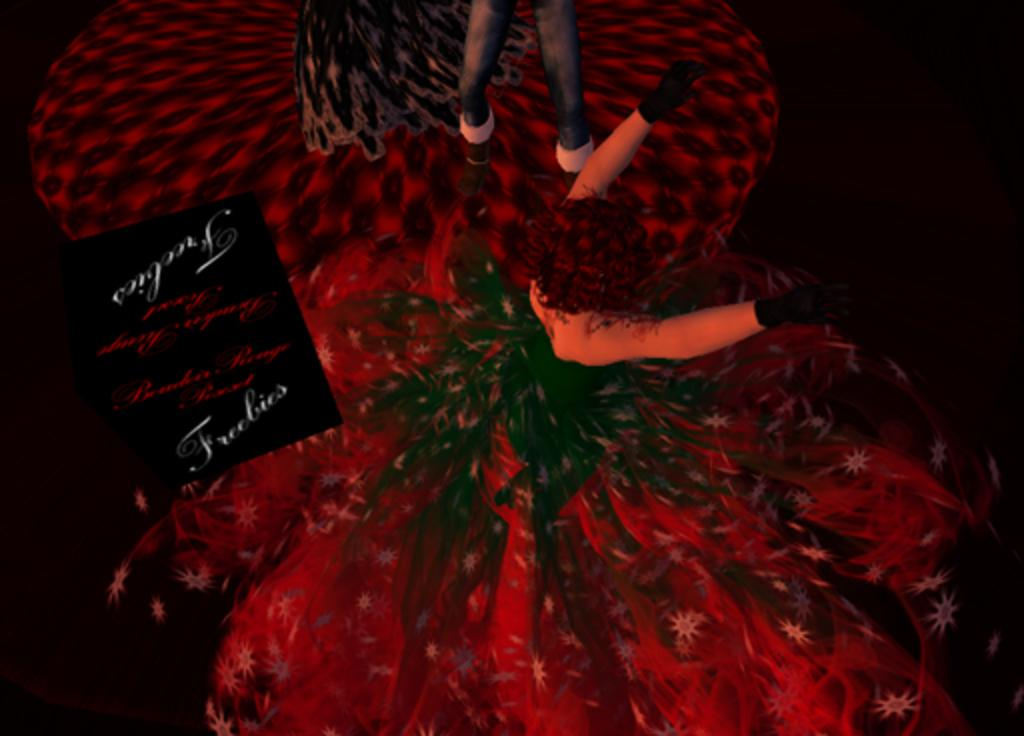What type of image is depicted in the picture? The image is an anime image. Can you describe the person in the image? There is a person standing in the back of the image. Where is the person located in relation to the ground? The person is standing on the floor. What is the person's nerve condition in the image? There is no information about the person's nerve condition in the image. How much wealth does the person have in the image? There is no information about the person's wealth in the image. 